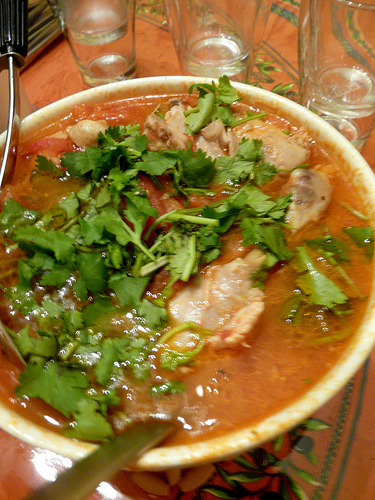<image>
Is the food next to the plate? No. The food is not positioned next to the plate. They are located in different areas of the scene. 